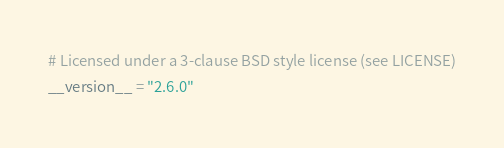Convert code to text. <code><loc_0><loc_0><loc_500><loc_500><_Python_># Licensed under a 3-clause BSD style license (see LICENSE)
__version__ = "2.6.0"
</code> 